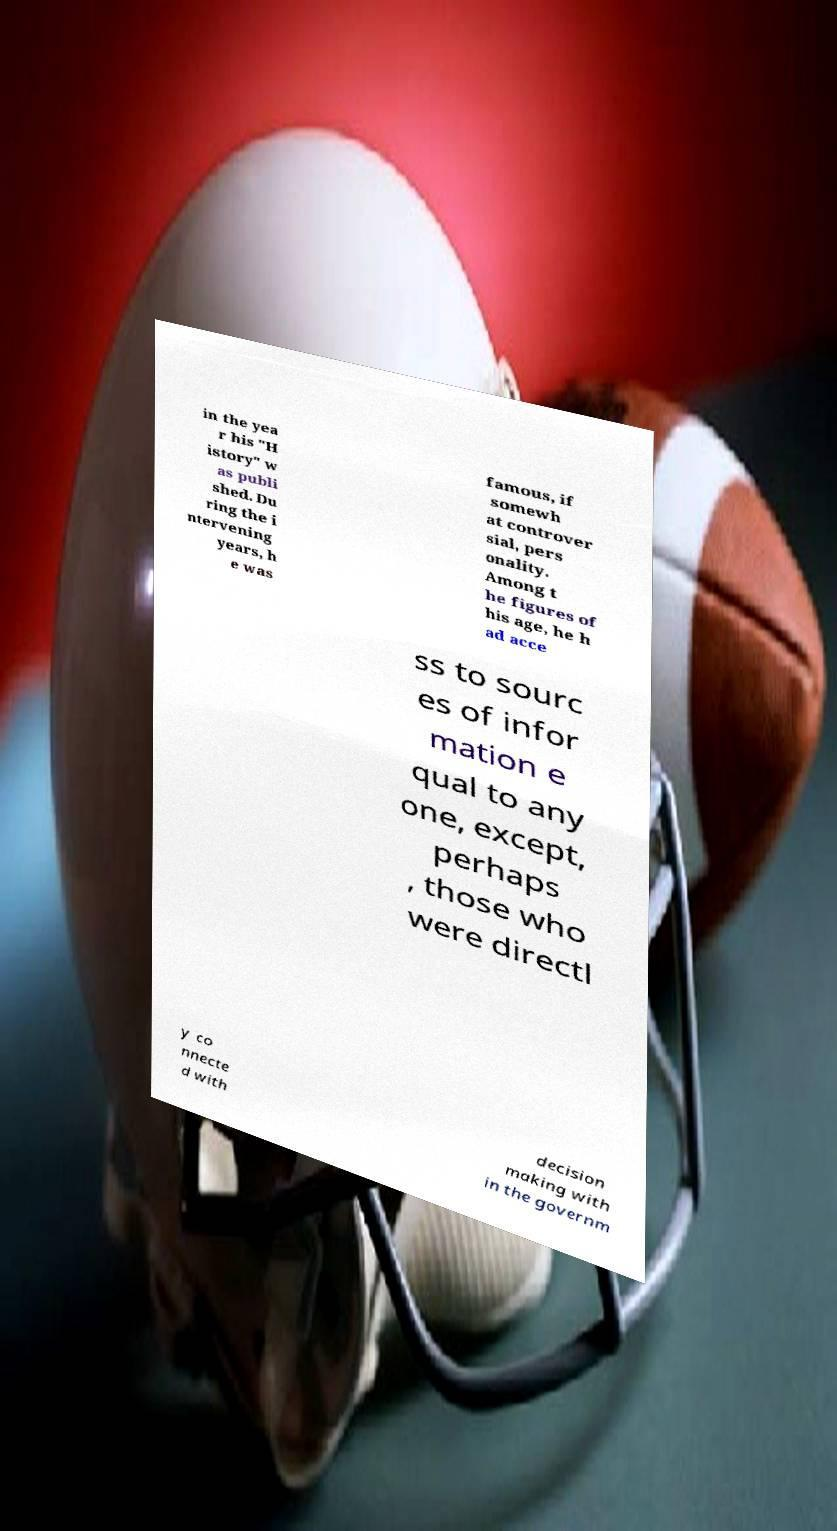There's text embedded in this image that I need extracted. Can you transcribe it verbatim? in the yea r his "H istory" w as publi shed. Du ring the i ntervening years, h e was famous, if somewh at controver sial, pers onality. Among t he figures of his age, he h ad acce ss to sourc es of infor mation e qual to any one, except, perhaps , those who were directl y co nnecte d with decision making with in the governm 